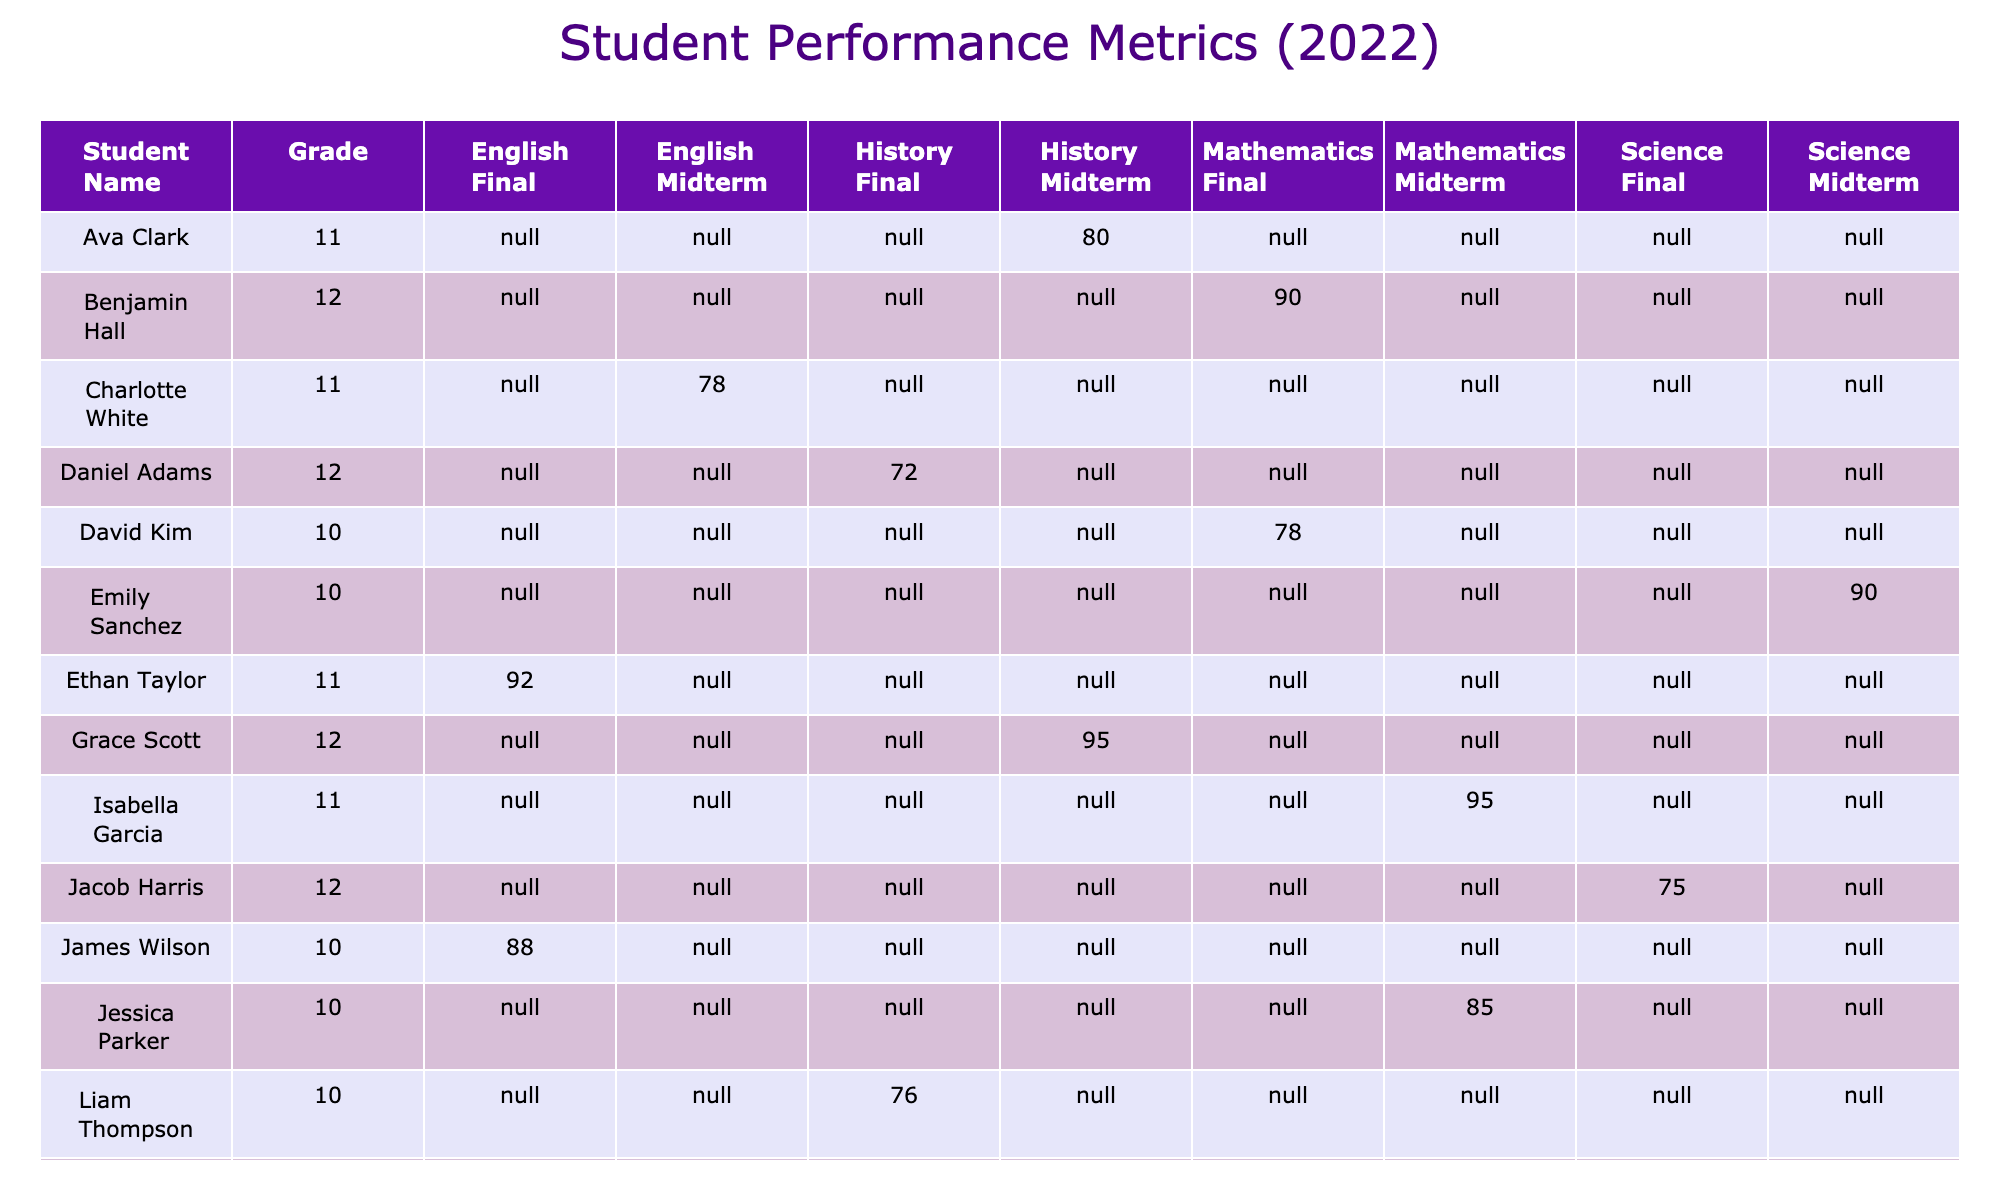What score did Jessica Parker receive in her Mathematics Midterm? Referring to the table, Jessica Parker's score in Mathematics for the Midterm is clearly listed as 85.
Answer: 85 What is the difference between David Kim's Final score and Emily Sanchez's Midterm score? David Kim's Final score in Mathematics is 78, and Emily Sanchez's Midterm score in Science is 90. The difference is 90 - 78 = 12.
Answer: 12 Did Mia Robinson score higher in Science Midterm or Final? Mia Robinson's Midterm score in Science is 88, while her Final score is 85. Since 88 is greater than 85, she scored higher in the Midterm.
Answer: Yes What is the average score for English Midterms across all grades? The scores for English Midterms are 74 (Sophia Martinez), 78 (Charlotte White), and 82 (Zoe King). To find the average, add these scores: 74 + 78 + 82 = 234, then divide by 3 (number of students): 234 / 3 = 78.
Answer: 78 Which student had the highest score in History Final? The table shows that Liam Thompson scored 76, Oliver Anderson scored 85, and Daniel Adams scored 72 in History Final. The highest score among these is 85 from Oliver Anderson.
Answer: Oliver Anderson What is the combined score of Lily Lewis in Mathematics for both assessments? Lily Lewis scored 98 in the Midterm and 90 in the Final. Adding these two scores gives 98 + 90 = 188 as her combined score.
Answer: 188 Is Ethan Taylor's score in English Final higher than the average score of the Science Midterm? Ethan Taylor scored 92 in English Final. The Science Midterm scores are 90 (Emily Sanchez) and 88 (Mia Robinson), yielding an average of (90 + 88) / 2 = 89. Since 92 is greater than 89, it confirms the statement.
Answer: Yes Which subject had the lowest average score across all grades? The average scores for each subject are as follows: Mathematics (average of 82.33), Science (average of 83.25), English (average of 80.5), History (average of 78.75). Since 78.75 is the lowest, History had the lowest average score.
Answer: History Who scored the lowest in the Midterm assessments? Reviewing the Midterm scores across all subjects: 74 (Sophia Martinez, English), 85 (Jessica Parker, Mathematics), 90 (Emily Sanchez, Science), and 92 (Olivia Johnson, History), the lowest score is 74.
Answer: Sophia Martinez What score did Jacob Harris achieve in his Science Final, and how does it compare to that of David Kim in Mathematics Final? Jacob Harris scored 75 in Science Final, while David Kim scored 78 in Mathematics Final. Comparing them, 75 is lower than 78.
Answer: Jacob Harris scored lower 